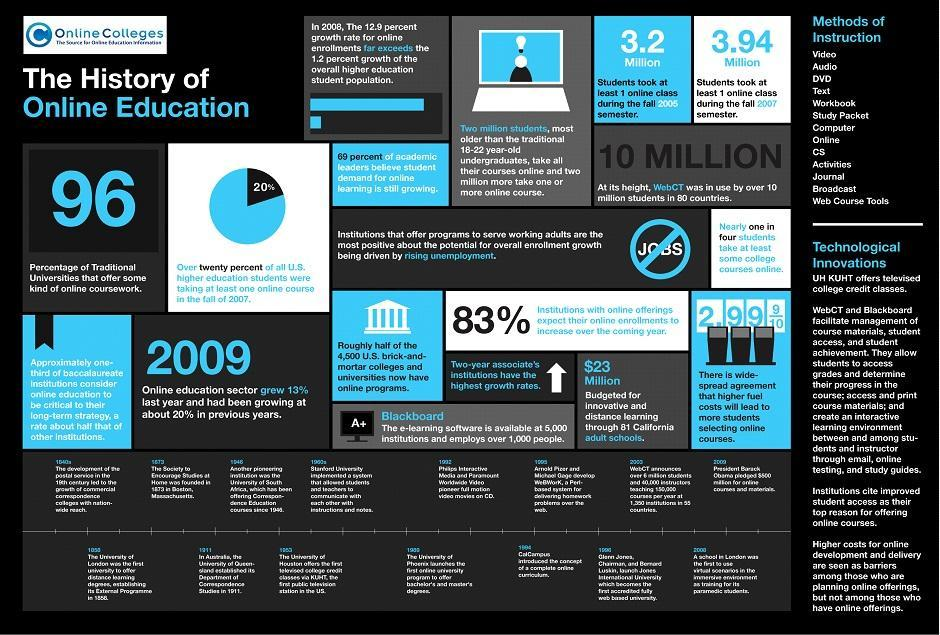What is the number of methods of instructions?
Answer the question with a short phrase. 13 What percentage of traditional universities offer online coursework? 96 